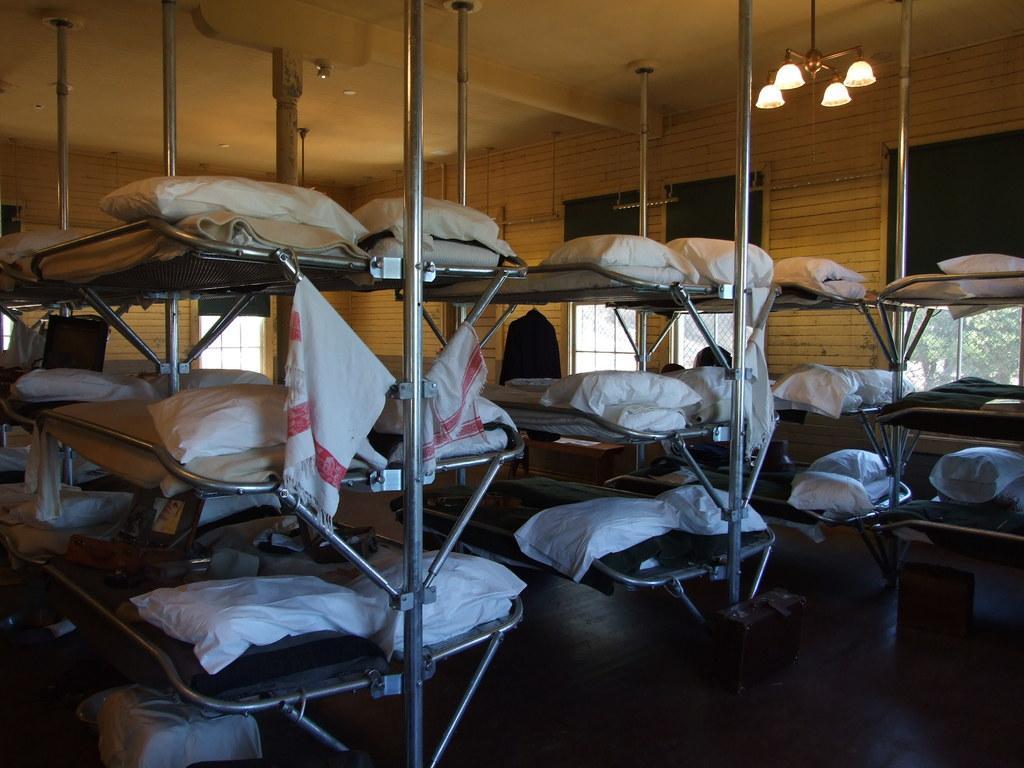Describe this image in one or two sentences. In this image I can see the bunker beds and there are pillows on it. In the background I can see the windows and there are lights in the top. I can see the trees through the window. 